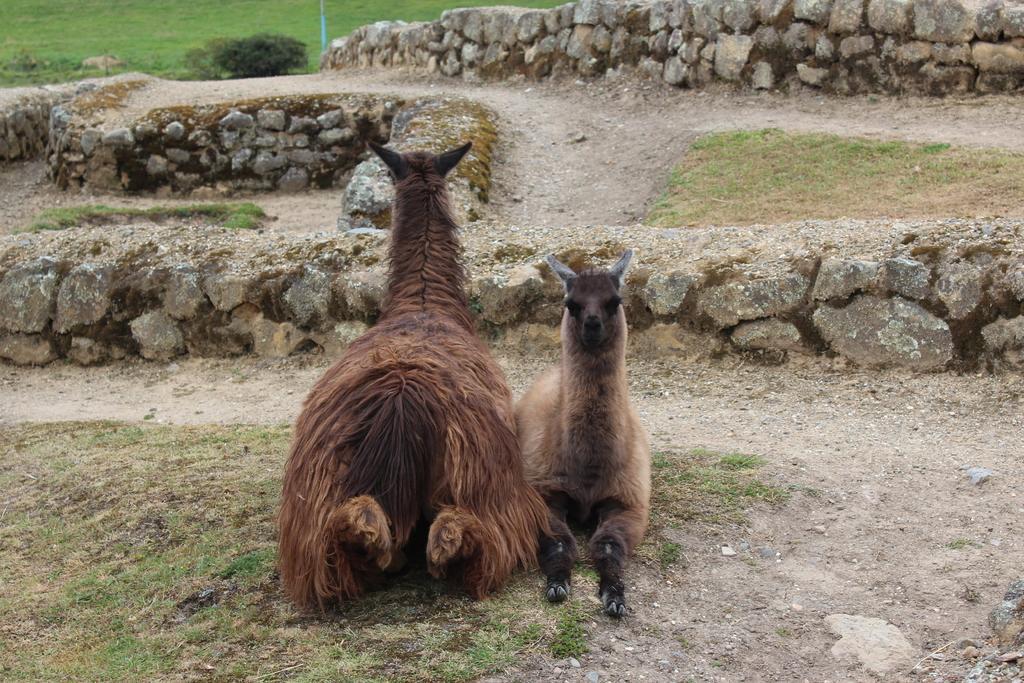Can you describe this image briefly? In this picture we see couple of animals seated on the ground and we see a plant and grass on the ground and few rocks. 